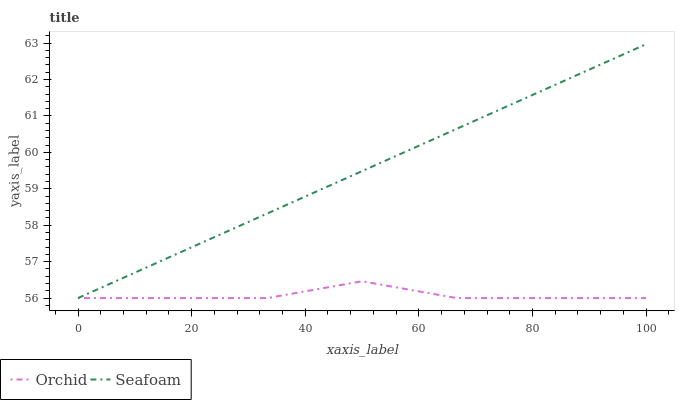Does Orchid have the minimum area under the curve?
Answer yes or no. Yes. Does Seafoam have the maximum area under the curve?
Answer yes or no. Yes. Does Orchid have the maximum area under the curve?
Answer yes or no. No. Is Seafoam the smoothest?
Answer yes or no. Yes. Is Orchid the roughest?
Answer yes or no. Yes. Is Orchid the smoothest?
Answer yes or no. No. Does Seafoam have the highest value?
Answer yes or no. Yes. Does Orchid have the highest value?
Answer yes or no. No. Does Seafoam intersect Orchid?
Answer yes or no. Yes. Is Seafoam less than Orchid?
Answer yes or no. No. Is Seafoam greater than Orchid?
Answer yes or no. No. 